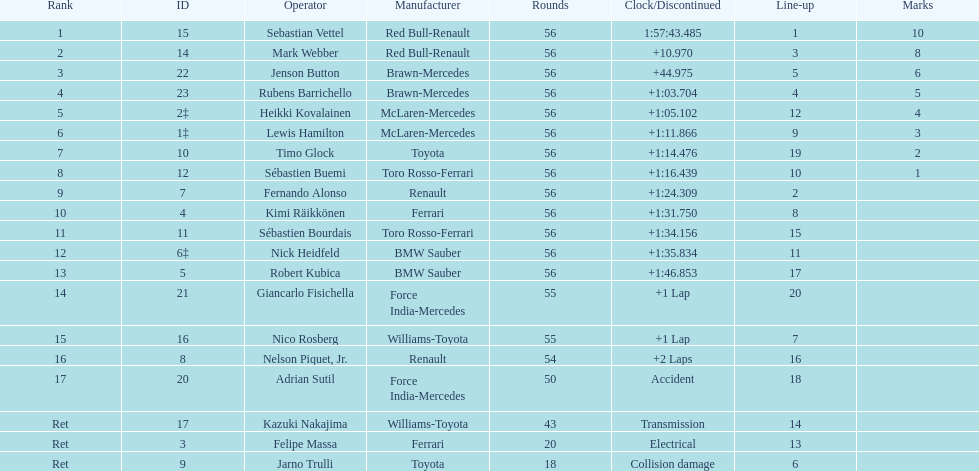How many drivers were unable to finish 56 laps? 7. 